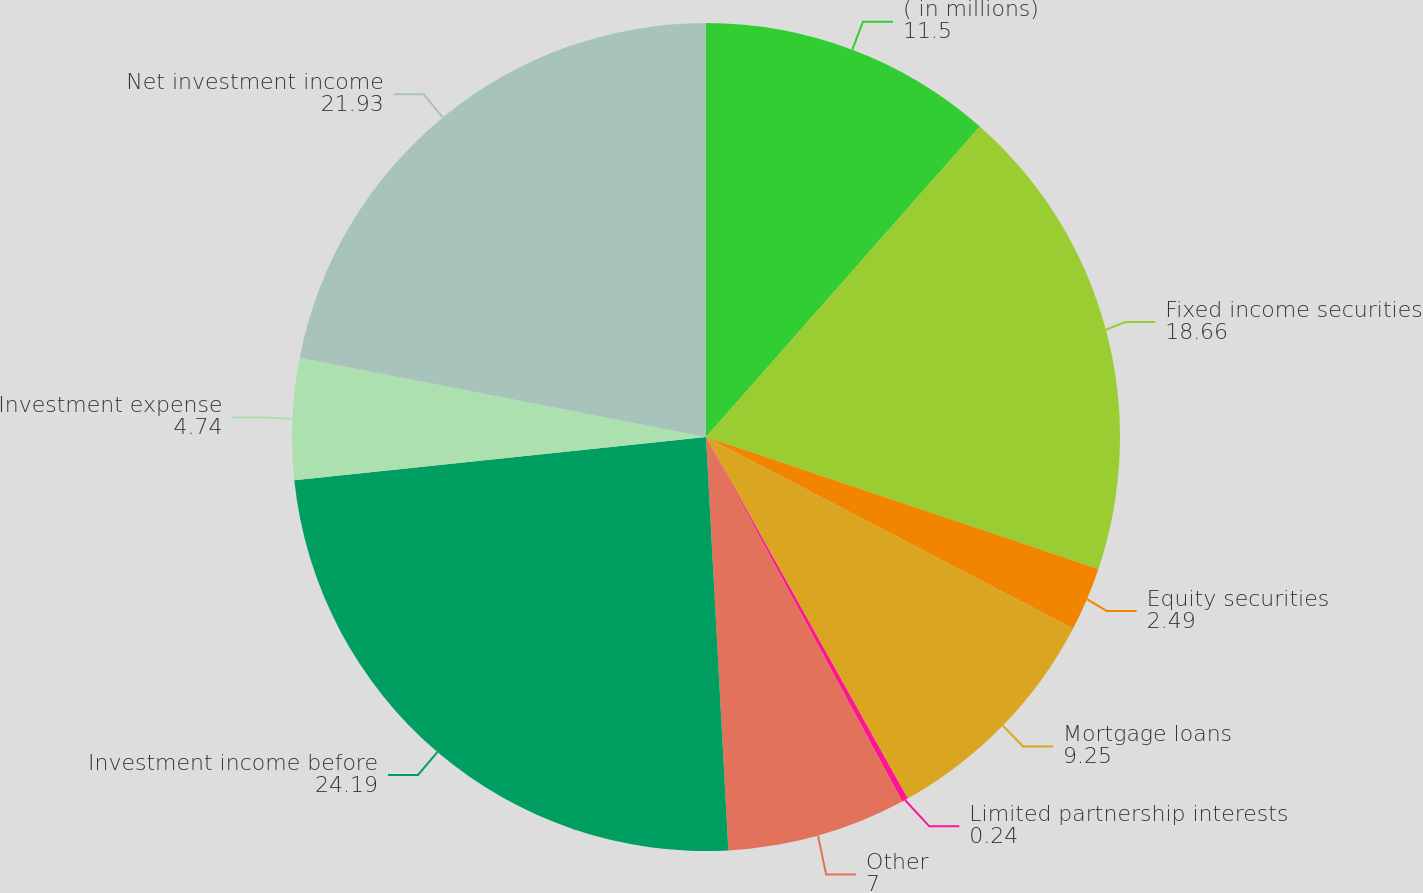<chart> <loc_0><loc_0><loc_500><loc_500><pie_chart><fcel>( in millions)<fcel>Fixed income securities<fcel>Equity securities<fcel>Mortgage loans<fcel>Limited partnership interests<fcel>Other<fcel>Investment income before<fcel>Investment expense<fcel>Net investment income<nl><fcel>11.5%<fcel>18.66%<fcel>2.49%<fcel>9.25%<fcel>0.24%<fcel>7.0%<fcel>24.19%<fcel>4.74%<fcel>21.93%<nl></chart> 